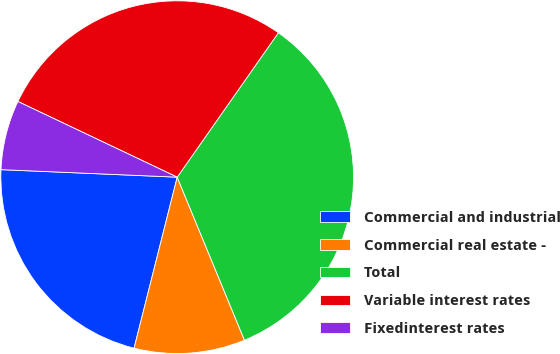Convert chart. <chart><loc_0><loc_0><loc_500><loc_500><pie_chart><fcel>Commercial and industrial<fcel>Commercial real estate -<fcel>Total<fcel>Variable interest rates<fcel>Fixedinterest rates<nl><fcel>21.75%<fcel>10.16%<fcel>34.05%<fcel>27.67%<fcel>6.38%<nl></chart> 